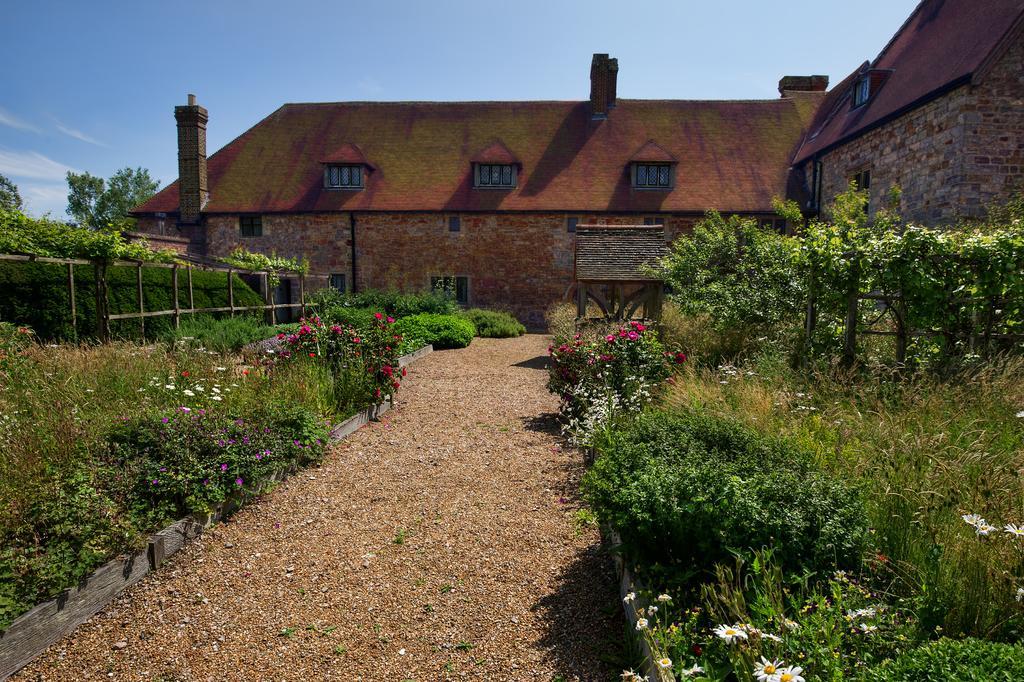How would you summarize this image in a sentence or two? In the picture we can see a mud path on the either sides of the path we can see different kinds of plants with flowers which are different colors like red, pink, and white in color and behind it, we can see a railing and some plants behind it and in the background we can see house building with windows to it and behind it we can see some trees and sky with clouds. 